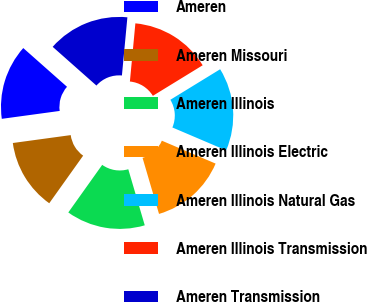Convert chart to OTSL. <chart><loc_0><loc_0><loc_500><loc_500><pie_chart><fcel>Ameren<fcel>Ameren Missouri<fcel>Ameren Illinois<fcel>Ameren Illinois Electric<fcel>Ameren Illinois Natural Gas<fcel>Ameren Illinois Transmission<fcel>Ameren Transmission<nl><fcel>13.69%<fcel>12.99%<fcel>14.4%<fcel>14.04%<fcel>15.17%<fcel>14.75%<fcel>14.96%<nl></chart> 